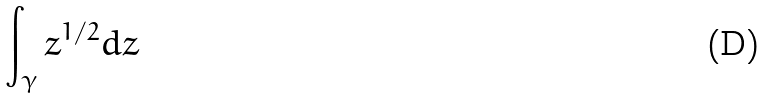Convert formula to latex. <formula><loc_0><loc_0><loc_500><loc_500>\int _ { \gamma } z ^ { 1 / 2 } d z</formula> 